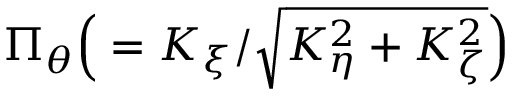Convert formula to latex. <formula><loc_0><loc_0><loc_500><loc_500>\Pi _ { \theta } \left ( = K _ { \xi } / \sqrt { K _ { \eta } ^ { 2 } + K _ { \zeta } ^ { 2 } } \right )</formula> 